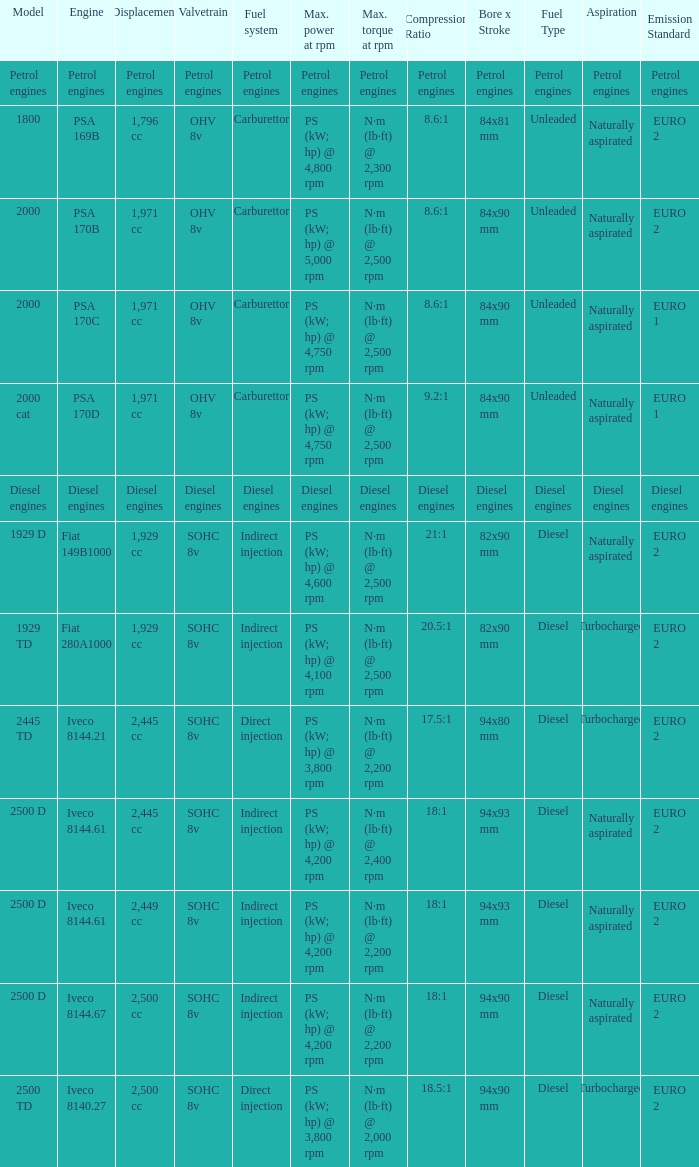What Valvetrain has a fuel system made up of petrol engines? Petrol engines. 